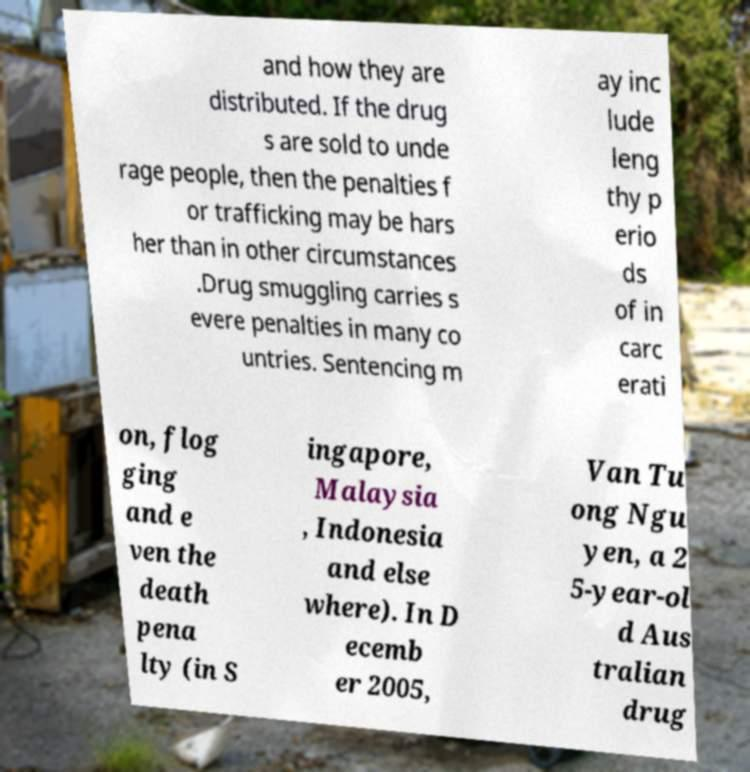Can you read and provide the text displayed in the image?This photo seems to have some interesting text. Can you extract and type it out for me? and how they are distributed. If the drug s are sold to unde rage people, then the penalties f or trafficking may be hars her than in other circumstances .Drug smuggling carries s evere penalties in many co untries. Sentencing m ay inc lude leng thy p erio ds of in carc erati on, flog ging and e ven the death pena lty (in S ingapore, Malaysia , Indonesia and else where). In D ecemb er 2005, Van Tu ong Ngu yen, a 2 5-year-ol d Aus tralian drug 